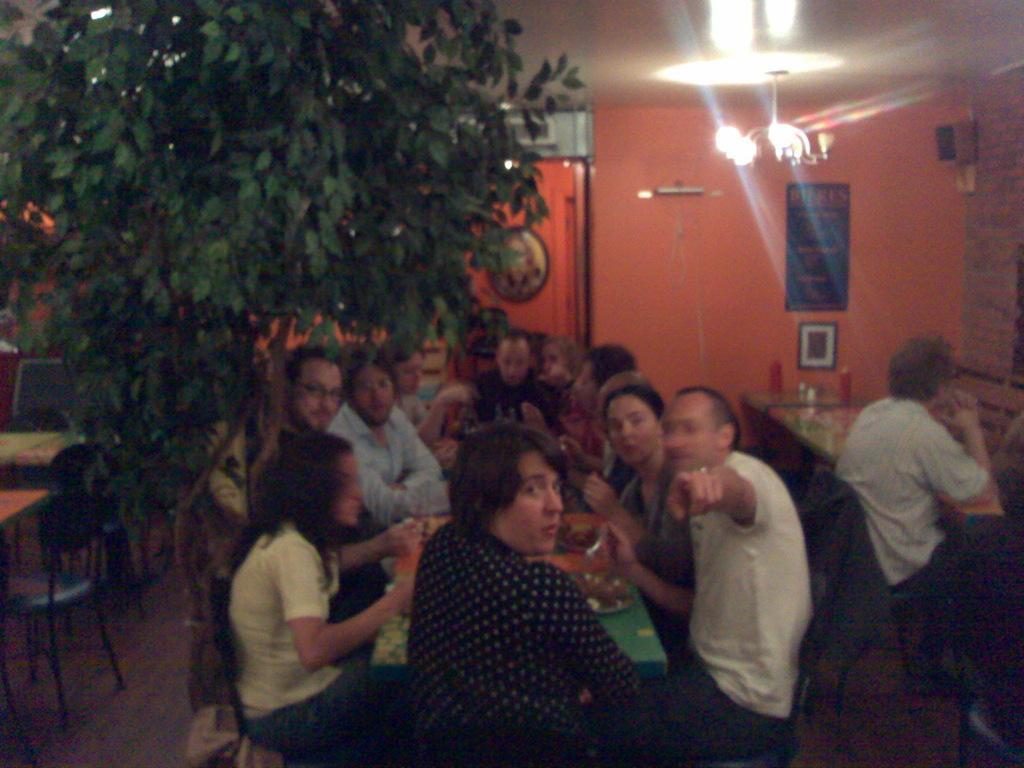How would you summarize this image in a sentence or two? In this image in center there are a group of people who are sitting on chairs, and it seems that they are eating and there is a table. On the table there are objects, and on the right side of the image there is one person sitting on chair and there are tables. On the tables there are objects, and on the left side also there are tables and chairs and in the foreground there is a plant. And in the background there is a wall, posters, lights, photo frames, door and at the top there is ceiling and lights at the bottom there is floor. 